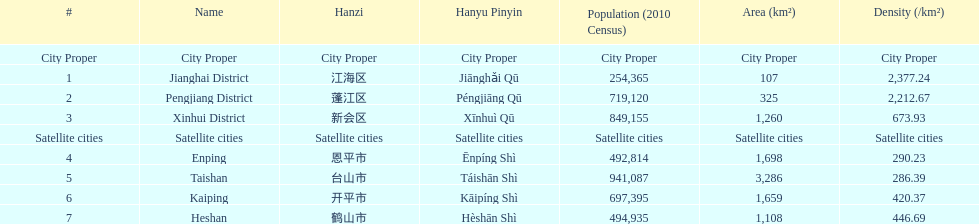Is enping more/less dense than kaiping? Less. 